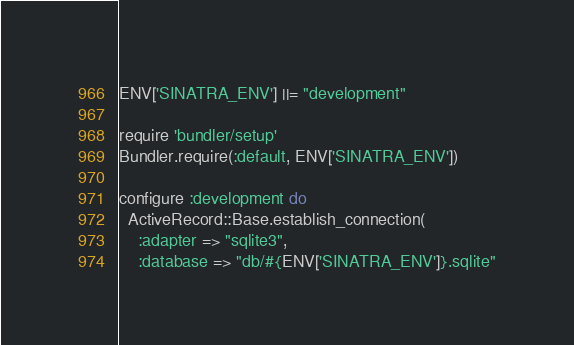<code> <loc_0><loc_0><loc_500><loc_500><_Ruby_>ENV['SINATRA_ENV'] ||= "development"

require 'bundler/setup'
Bundler.require(:default, ENV['SINATRA_ENV'])

configure :development do
  ActiveRecord::Base.establish_connection(
    :adapter => "sqlite3",
    :database => "db/#{ENV['SINATRA_ENV']}.sqlite"</code> 